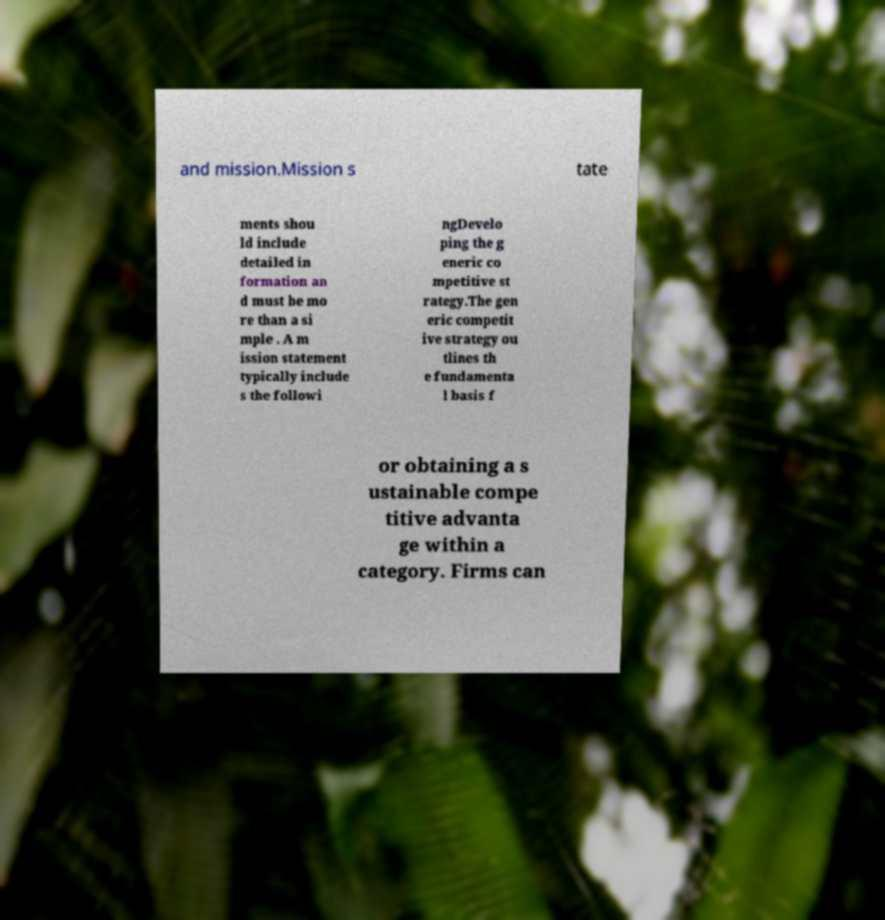Could you assist in decoding the text presented in this image and type it out clearly? and mission.Mission s tate ments shou ld include detailed in formation an d must be mo re than a si mple . A m ission statement typically include s the followi ngDevelo ping the g eneric co mpetitive st rategy.The gen eric competit ive strategy ou tlines th e fundamenta l basis f or obtaining a s ustainable compe titive advanta ge within a category. Firms can 